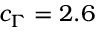<formula> <loc_0><loc_0><loc_500><loc_500>c _ { \Gamma } = 2 . 6</formula> 